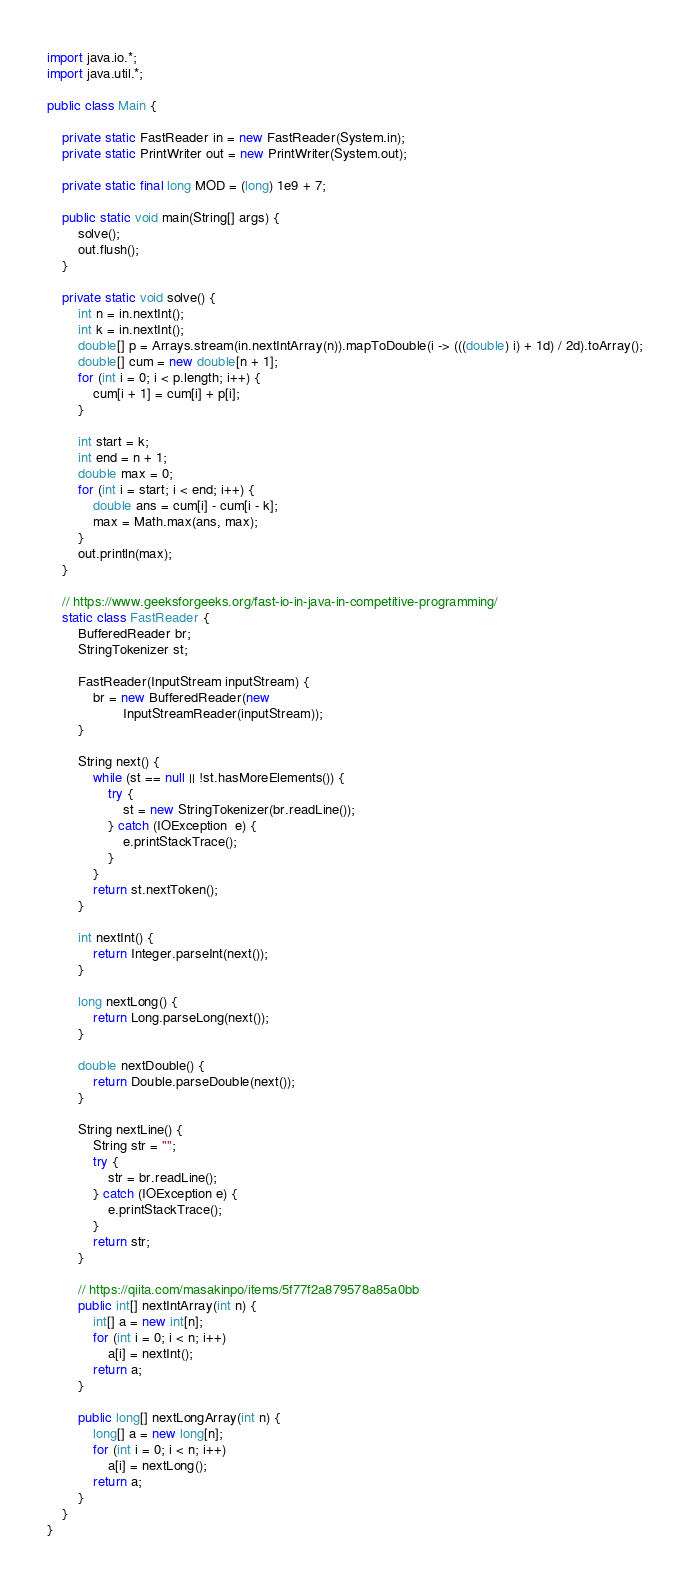Convert code to text. <code><loc_0><loc_0><loc_500><loc_500><_Java_>import java.io.*;
import java.util.*;

public class Main {

    private static FastReader in = new FastReader(System.in);
    private static PrintWriter out = new PrintWriter(System.out);

    private static final long MOD = (long) 1e9 + 7;

    public static void main(String[] args) {
        solve();
        out.flush();
    }

    private static void solve() {
        int n = in.nextInt();
        int k = in.nextInt();
        double[] p = Arrays.stream(in.nextIntArray(n)).mapToDouble(i -> (((double) i) + 1d) / 2d).toArray();
        double[] cum = new double[n + 1];
        for (int i = 0; i < p.length; i++) {
            cum[i + 1] = cum[i] + p[i];
        }

        int start = k;
        int end = n + 1;
        double max = 0;
        for (int i = start; i < end; i++) {
            double ans = cum[i] - cum[i - k];
            max = Math.max(ans, max);
        }
        out.println(max);
    }

    // https://www.geeksforgeeks.org/fast-io-in-java-in-competitive-programming/
    static class FastReader {
        BufferedReader br;
        StringTokenizer st;

        FastReader(InputStream inputStream) {
            br = new BufferedReader(new
                    InputStreamReader(inputStream));
        }

        String next() {
            while (st == null || !st.hasMoreElements()) {
                try {
                    st = new StringTokenizer(br.readLine());
                } catch (IOException  e) {
                    e.printStackTrace();
                }
            }
            return st.nextToken();
        }

        int nextInt() {
            return Integer.parseInt(next());
        }

        long nextLong() {
            return Long.parseLong(next());
        }

        double nextDouble() {
            return Double.parseDouble(next());
        }

        String nextLine() {
            String str = "";
            try {
                str = br.readLine();
            } catch (IOException e) {
                e.printStackTrace();
            }
            return str;
        }

        // https://qiita.com/masakinpo/items/5f77f2a879578a85a0bb
        public int[] nextIntArray(int n) {
            int[] a = new int[n];
            for (int i = 0; i < n; i++)
                a[i] = nextInt();
            return a;
        }

        public long[] nextLongArray(int n) {
            long[] a = new long[n];
            for (int i = 0; i < n; i++)
                a[i] = nextLong();
            return a;
        }
    }
}
</code> 